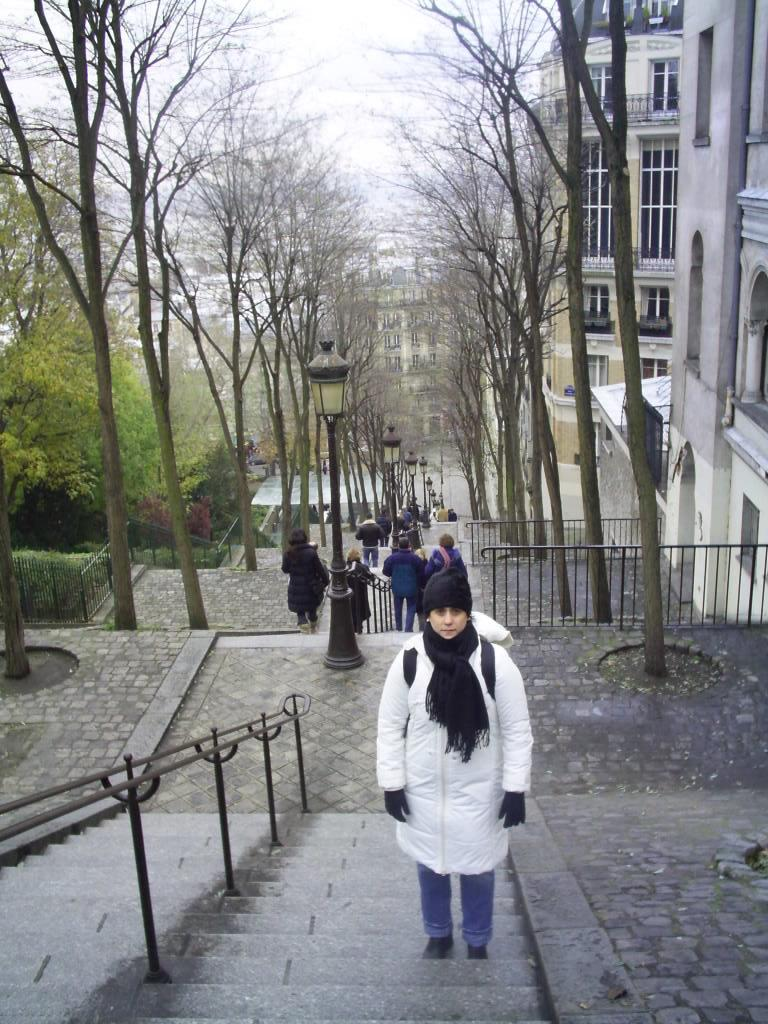What are the people in the image doing? There are people climbing a staircase in the image. Where is the staircase located in the image? The staircase is in the center of the image. What can be seen in the background of the image? There are buildings and trees in the background of the image. What feature of the staircase is visible in the image? There is a staircase railing visible in the image. How many girls are holding a feather in the image? There are no girls or feathers present in the image. 